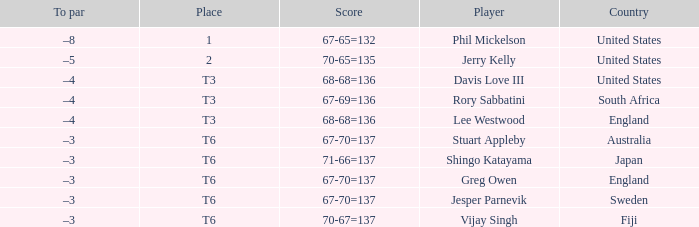Name the score for vijay singh 70-67=137. 